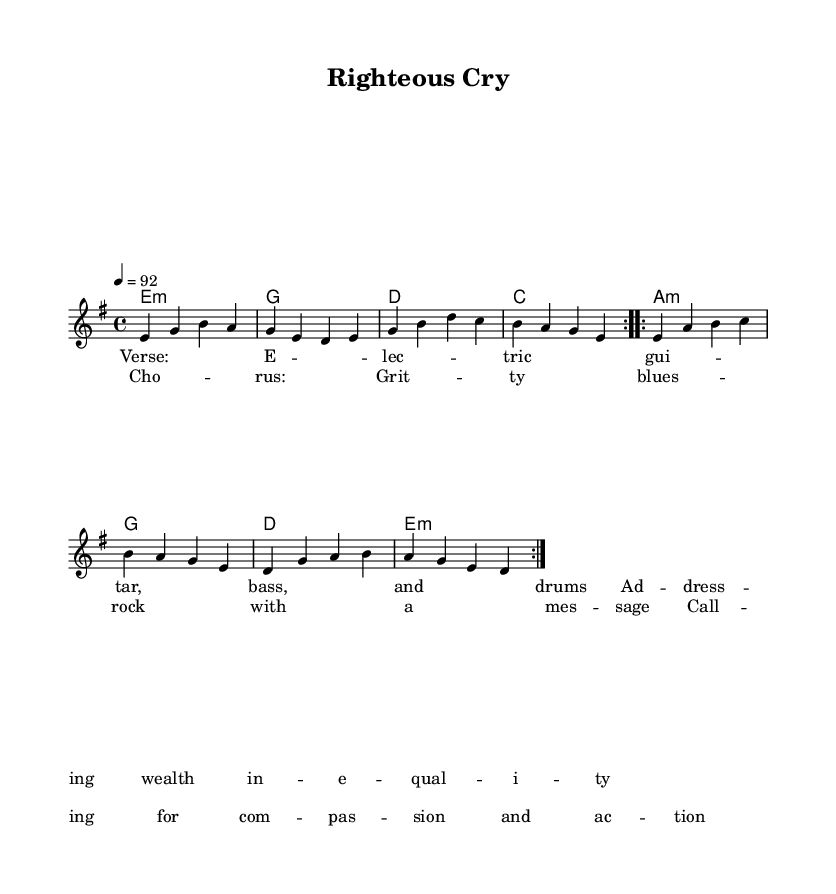What is the key signature of this music? The key signature is E minor, which has one sharp (F#). It can be determined by identifying the key indicated at the beginning of the music and recognizing the related minor scale.
Answer: E minor What is the time signature of this music? The time signature is four-four, which is indicated in the notation. It means there are four beats in each measure and the quarter note gets one beat.
Answer: Four-four What is the tempo marking for this piece? The tempo marking is 92 beats per minute. This is noted in the tempo instruction at the beginning of the score.
Answer: 92 How many times is the verse repeated? The verse is repeated two times as indicated by "repeat volta 2" in the melody section of the score.
Answer: Two What type of lyrics accompany the chorus section? The lyrics accompanying the chorus section contain a social justice message, evident in the wording that calls for compassion and action.
Answer: Social justice message What is the structure of the song based on the sheet music? The structure consists of verses and a chorus, where the music alternates between playing chord progressions and the lyrics in respective sections based on the repeat markings provided.
Answer: Verse-Chorus structure 